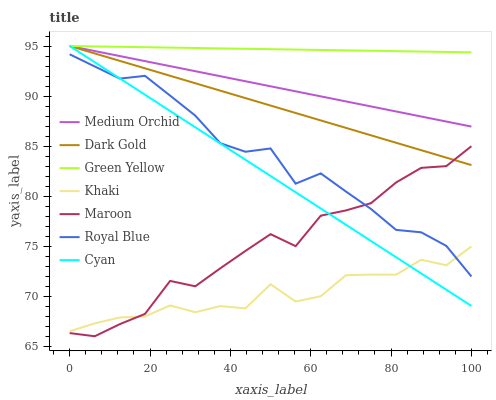Does Khaki have the minimum area under the curve?
Answer yes or no. Yes. Does Green Yellow have the maximum area under the curve?
Answer yes or no. Yes. Does Dark Gold have the minimum area under the curve?
Answer yes or no. No. Does Dark Gold have the maximum area under the curve?
Answer yes or no. No. Is Green Yellow the smoothest?
Answer yes or no. Yes. Is Maroon the roughest?
Answer yes or no. Yes. Is Dark Gold the smoothest?
Answer yes or no. No. Is Dark Gold the roughest?
Answer yes or no. No. Does Maroon have the lowest value?
Answer yes or no. Yes. Does Dark Gold have the lowest value?
Answer yes or no. No. Does Green Yellow have the highest value?
Answer yes or no. Yes. Does Maroon have the highest value?
Answer yes or no. No. Is Royal Blue less than Medium Orchid?
Answer yes or no. Yes. Is Medium Orchid greater than Royal Blue?
Answer yes or no. Yes. Does Royal Blue intersect Maroon?
Answer yes or no. Yes. Is Royal Blue less than Maroon?
Answer yes or no. No. Is Royal Blue greater than Maroon?
Answer yes or no. No. Does Royal Blue intersect Medium Orchid?
Answer yes or no. No. 